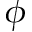Convert formula to latex. <formula><loc_0><loc_0><loc_500><loc_500>\phi</formula> 